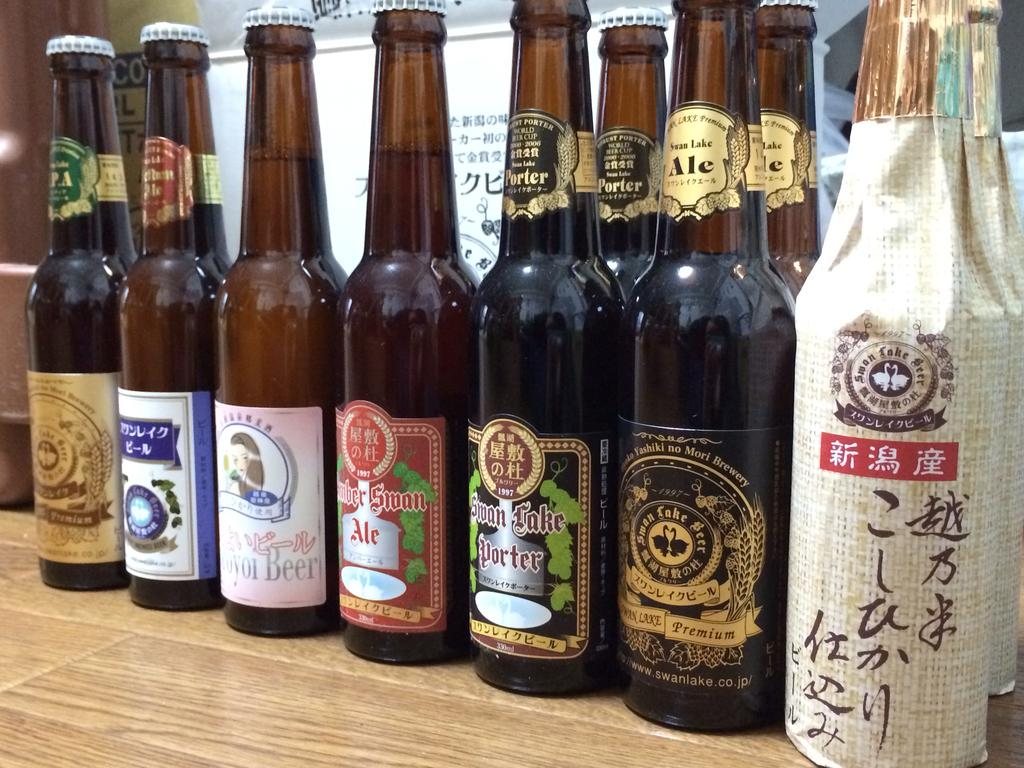<image>
Relay a brief, clear account of the picture shown. bottles of alochol next to one another with one labeled 'swan lake porter' 